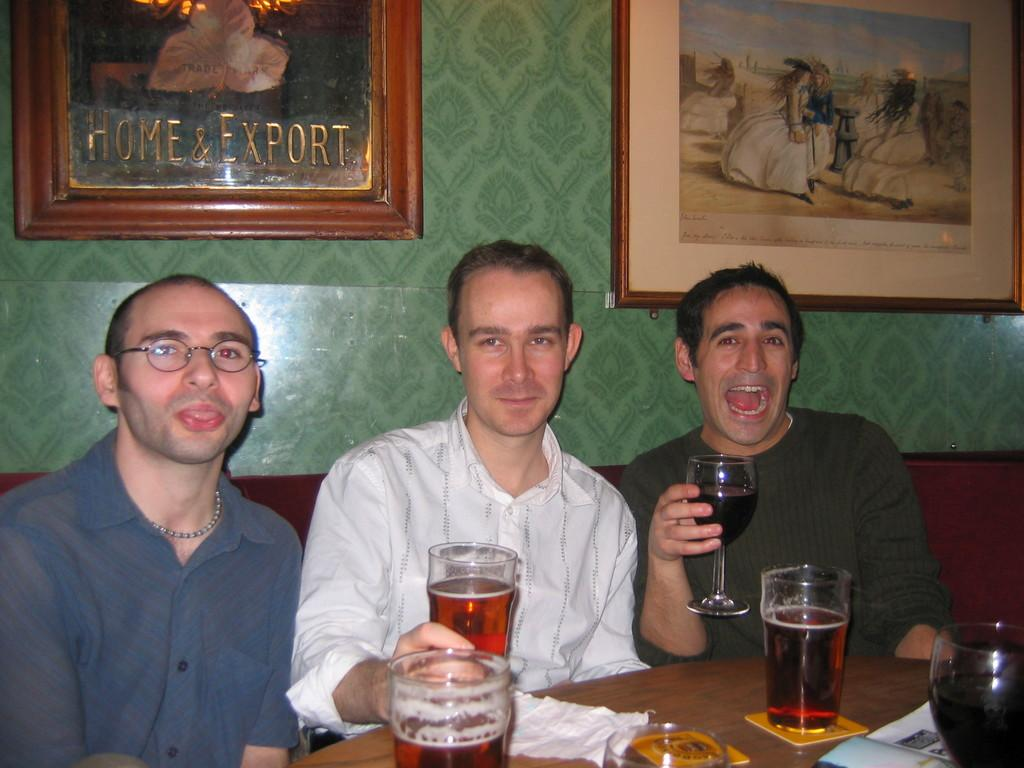What are the persons in the image doing? The persons in the image are sitting on the sofa. What objects can be seen on the table in the image? There is a glass, a paper, and a drink on the table in the image. What is hanging on the wall in the image? There are photo frames on the wall in the image. Is there any mention of insurance or competition in the image? No, there is no mention of insurance or competition in the image. Can you see any cobwebs in the image? No, there are no cobwebs visible in the image. 